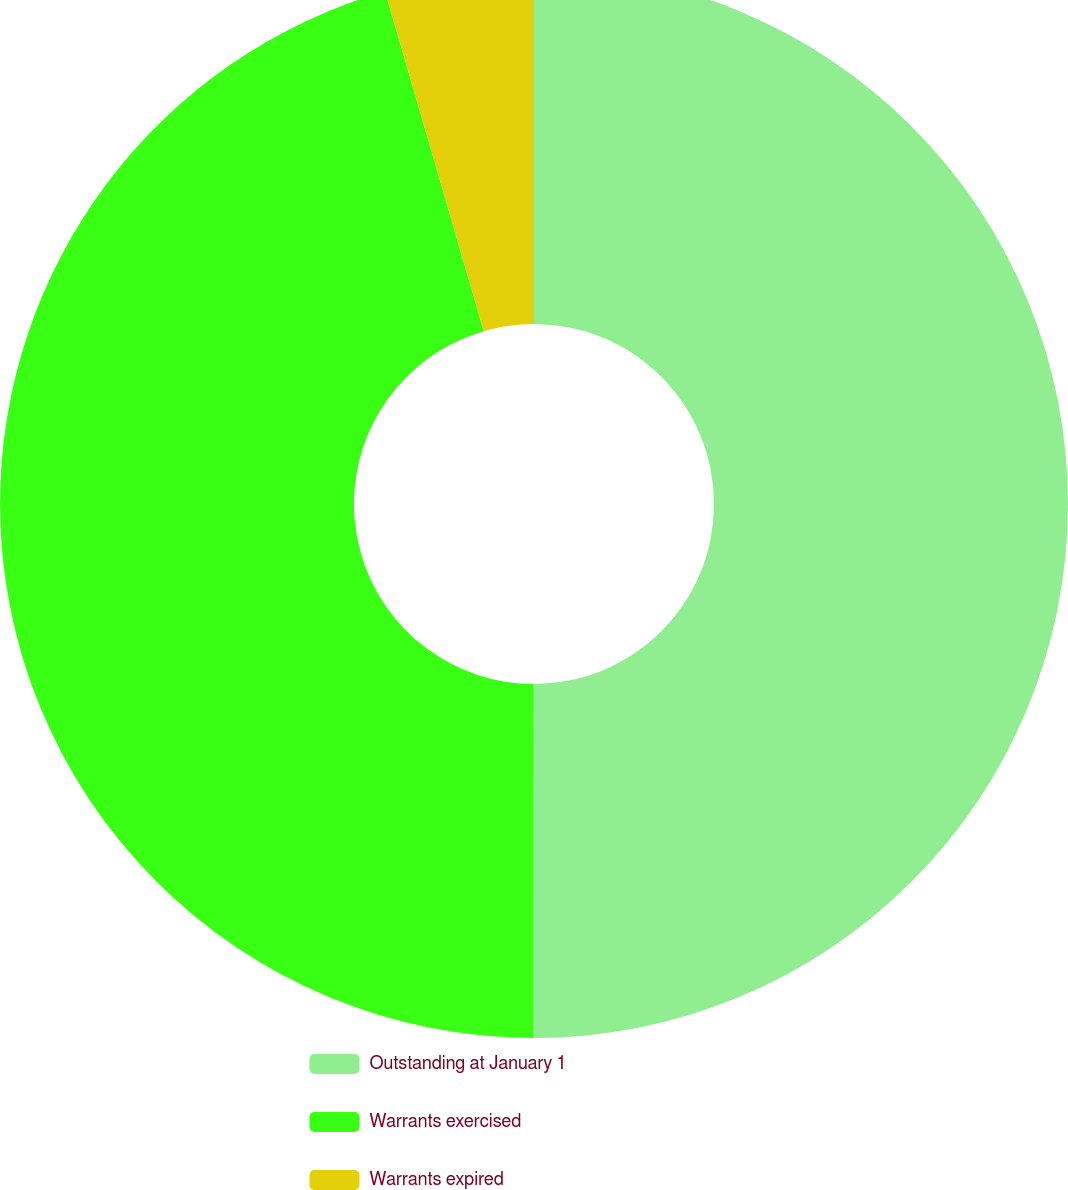Convert chart. <chart><loc_0><loc_0><loc_500><loc_500><pie_chart><fcel>Outstanding at January 1<fcel>Warrants exercised<fcel>Warrants expired<nl><fcel>50.03%<fcel>45.48%<fcel>4.5%<nl></chart> 